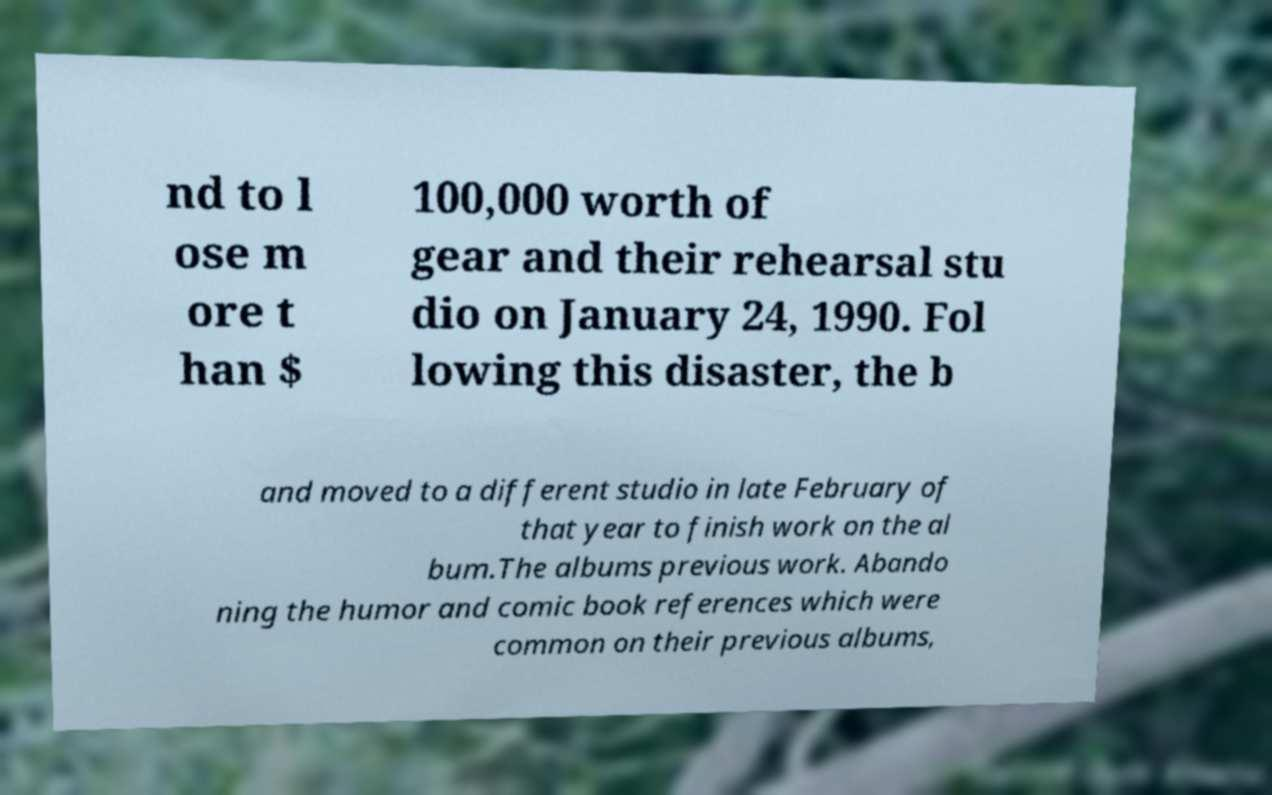There's text embedded in this image that I need extracted. Can you transcribe it verbatim? nd to l ose m ore t han $ 100,000 worth of gear and their rehearsal stu dio on January 24, 1990. Fol lowing this disaster, the b and moved to a different studio in late February of that year to finish work on the al bum.The albums previous work. Abando ning the humor and comic book references which were common on their previous albums, 